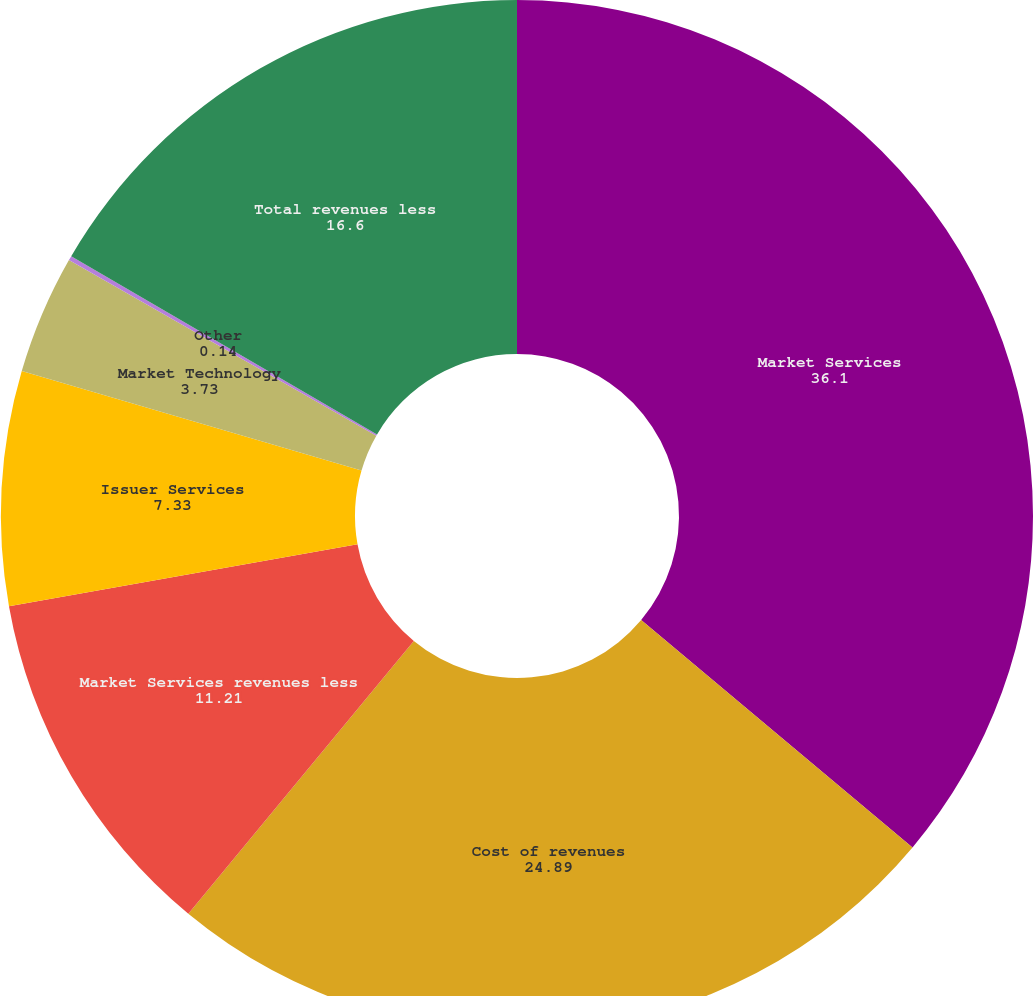Convert chart. <chart><loc_0><loc_0><loc_500><loc_500><pie_chart><fcel>Market Services<fcel>Cost of revenues<fcel>Market Services revenues less<fcel>Issuer Services<fcel>Market Technology<fcel>Other<fcel>Total revenues less<nl><fcel>36.1%<fcel>24.89%<fcel>11.21%<fcel>7.33%<fcel>3.73%<fcel>0.14%<fcel>16.6%<nl></chart> 